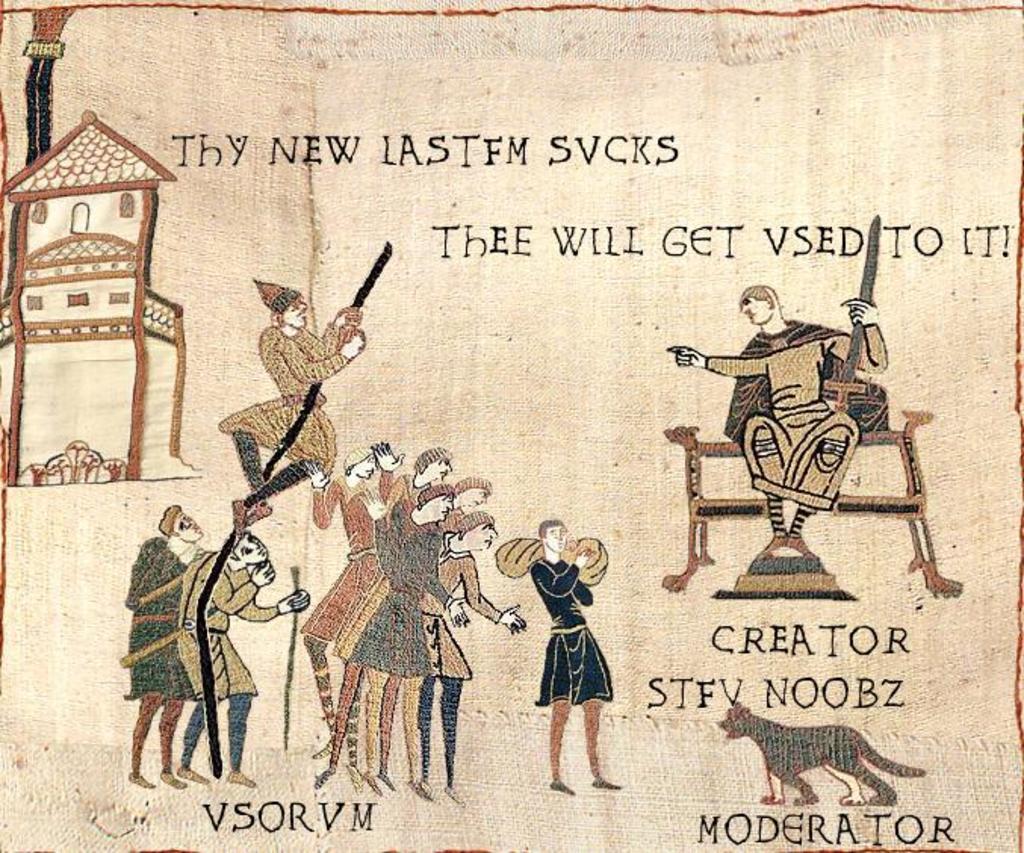Describe this image in one or two sentences. In this image I can see the art of few people and an animal. To the left I can see the house and something is written on the image. 